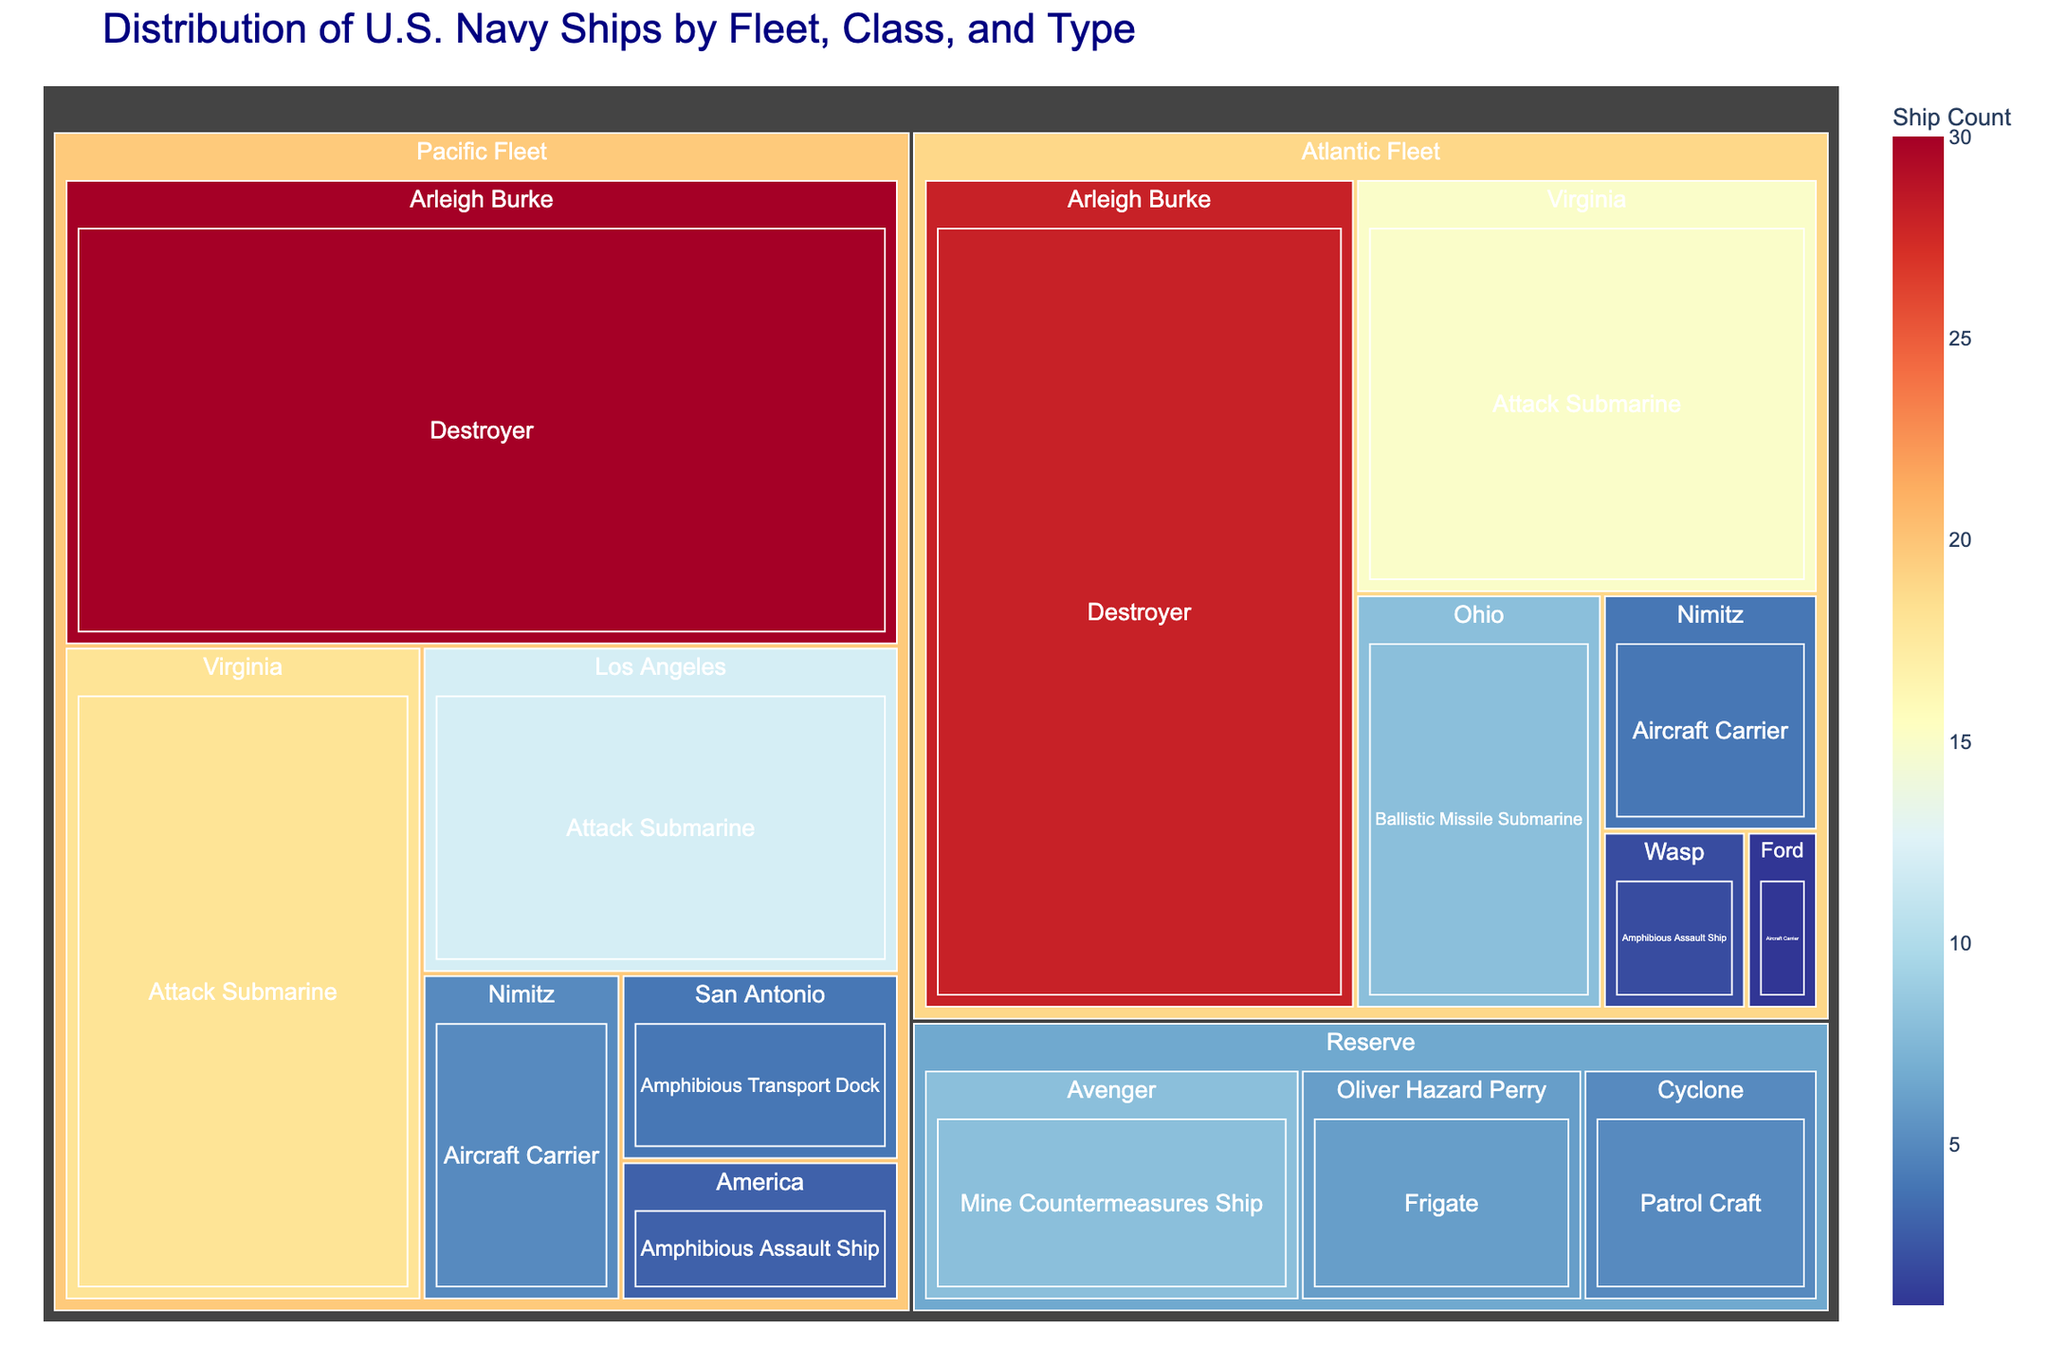What's the total number of ships in the Pacific Fleet? Sum the counts of all ships under the Pacific Fleet: 5 (Nimitz) + 3 (America) + 30 (Arleigh Burke) + 18 (Virginia) + 12 (Los Angeles) + 4 (San Antonio). This gives a total of 72 ships.
Answer: 72 Which fleet has the highest number of Arleigh Burke-class Destroyers? Compare the counts of Arleigh Burke-class Destroyers in the Pacific Fleet and Atlantic Fleet. The Pacific Fleet has 30, and the Atlantic Fleet has 28. Hence, the Pacific Fleet has more Arleigh Burke-class Destroyers.
Answer: Pacific Fleet How many types of ships are represented in the Reserve fleet? Count the distinct types of ships for the Reserve fleet: Frigate, Mine Countermeasures Ship, and Patrol Craft. There are 3 types.
Answer: 3 Which fleet has the most Aircraft Carriers? Compare the counts of Aircraft Carriers in the Pacific Fleet, Atlantic Fleet, and Reserve fleet. The Pacific Fleet has 5 Nimitz-class carriers, and the Atlantic Fleet has 1 Ford-class and 4 Nimitz-class carriers. The Pacific Fleet has more Aircraft Carriers with a total of 5.
Answer: Pacific Fleet What is the total number of Attack Submarines across all fleets? Add the counts of Attack Submarines from all fleets: Pacific Fleet (18 Virginia + 12 Los Angeles) and Atlantic Fleet (15 Virginia). This gives 18 + 12 + 15 = 45.
Answer: 45 Which type of U.S. Navy ships has the lowest representation as per the treemap? Find the type of ship with the minimum count across all fleets. The Ford-class Aircraft Carrier in the Atlantic Fleet has a count of 1, which is the lowest.
Answer: Ford-class Aircraft Carrier Compare the total number of ships between the Atlantic Fleet and the Reserve fleet. Sum the counts of all ships in Atlantic Fleet: 1 (Ford) + 4 (Nimitz) + 2 (Wasp) + 28 (Arleigh Burke) + 15 (Virginia) + 8 (Ohio), which gives 58. Sum the counts in the Reserve fleet: 6 (Oliver Hazard Perry) + 8 (Avenger) + 5 (Cyclone), which gives 19. The Atlantic Fleet has more ships.
Answer: Atlantic Fleet What is the ratio of Destroyers to Amphibious Assault Ships in the Pacific Fleet? The Pacific Fleet has 30 Arleigh Burke-class Destroyers and 3 America-class Amphibious Assault Ships. The ratio is 30:3 or simplified to 10:1.
Answer: 10:1 How many Nimitz-class Aircraft Carriers are there in total? Add the counts of Nimitz-class Aircraft Carriers in the Pacific Fleet (5) and Atlantic Fleet (4). This gives a total of 9.
Answer: 9 